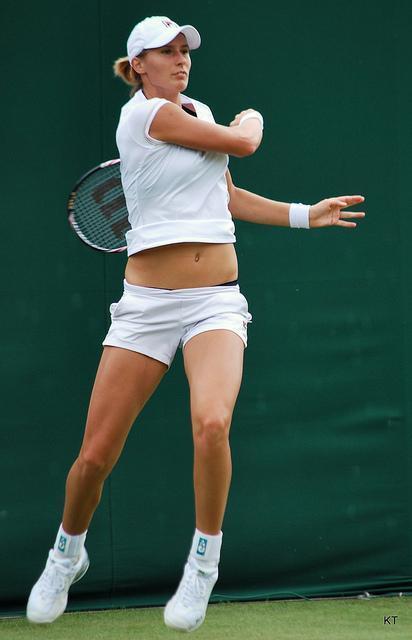How many cows are laying down?
Give a very brief answer. 0. 